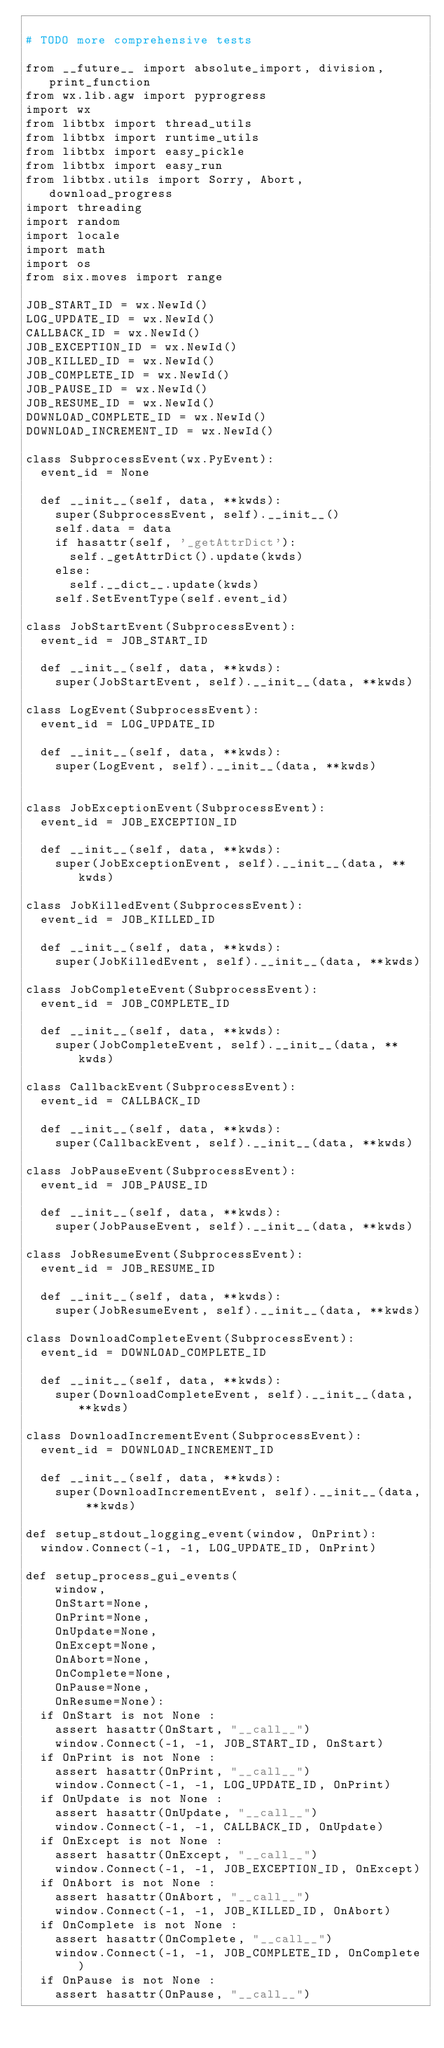Convert code to text. <code><loc_0><loc_0><loc_500><loc_500><_Python_>
# TODO more comprehensive tests

from __future__ import absolute_import, division, print_function
from wx.lib.agw import pyprogress
import wx
from libtbx import thread_utils
from libtbx import runtime_utils
from libtbx import easy_pickle
from libtbx import easy_run
from libtbx.utils import Sorry, Abort, download_progress
import threading
import random
import locale
import math
import os
from six.moves import range

JOB_START_ID = wx.NewId()
LOG_UPDATE_ID = wx.NewId()
CALLBACK_ID = wx.NewId()
JOB_EXCEPTION_ID = wx.NewId()
JOB_KILLED_ID = wx.NewId()
JOB_COMPLETE_ID = wx.NewId()
JOB_PAUSE_ID = wx.NewId()
JOB_RESUME_ID = wx.NewId()
DOWNLOAD_COMPLETE_ID = wx.NewId()
DOWNLOAD_INCREMENT_ID = wx.NewId()

class SubprocessEvent(wx.PyEvent):
  event_id = None

  def __init__(self, data, **kwds):
    super(SubprocessEvent, self).__init__()
    self.data = data
    if hasattr(self, '_getAttrDict'):
      self._getAttrDict().update(kwds)
    else:
      self.__dict__.update(kwds)
    self.SetEventType(self.event_id)

class JobStartEvent(SubprocessEvent):
  event_id = JOB_START_ID

  def __init__(self, data, **kwds):
    super(JobStartEvent, self).__init__(data, **kwds)

class LogEvent(SubprocessEvent):
  event_id = LOG_UPDATE_ID

  def __init__(self, data, **kwds):
    super(LogEvent, self).__init__(data, **kwds)


class JobExceptionEvent(SubprocessEvent):
  event_id = JOB_EXCEPTION_ID

  def __init__(self, data, **kwds):
    super(JobExceptionEvent, self).__init__(data, **kwds)

class JobKilledEvent(SubprocessEvent):
  event_id = JOB_KILLED_ID

  def __init__(self, data, **kwds):
    super(JobKilledEvent, self).__init__(data, **kwds)

class JobCompleteEvent(SubprocessEvent):
  event_id = JOB_COMPLETE_ID

  def __init__(self, data, **kwds):
    super(JobCompleteEvent, self).__init__(data, **kwds)

class CallbackEvent(SubprocessEvent):
  event_id = CALLBACK_ID

  def __init__(self, data, **kwds):
    super(CallbackEvent, self).__init__(data, **kwds)

class JobPauseEvent(SubprocessEvent):
  event_id = JOB_PAUSE_ID

  def __init__(self, data, **kwds):
    super(JobPauseEvent, self).__init__(data, **kwds)

class JobResumeEvent(SubprocessEvent):
  event_id = JOB_RESUME_ID

  def __init__(self, data, **kwds):
    super(JobResumeEvent, self).__init__(data, **kwds)

class DownloadCompleteEvent(SubprocessEvent):
  event_id = DOWNLOAD_COMPLETE_ID

  def __init__(self, data, **kwds):
    super(DownloadCompleteEvent, self).__init__(data, **kwds)

class DownloadIncrementEvent(SubprocessEvent):
  event_id = DOWNLOAD_INCREMENT_ID

  def __init__(self, data, **kwds):
    super(DownloadIncrementEvent, self).__init__(data, **kwds)

def setup_stdout_logging_event(window, OnPrint):
  window.Connect(-1, -1, LOG_UPDATE_ID, OnPrint)

def setup_process_gui_events(
    window,
    OnStart=None,
    OnPrint=None,
    OnUpdate=None,
    OnExcept=None,
    OnAbort=None,
    OnComplete=None,
    OnPause=None,
    OnResume=None):
  if OnStart is not None :
    assert hasattr(OnStart, "__call__")
    window.Connect(-1, -1, JOB_START_ID, OnStart)
  if OnPrint is not None :
    assert hasattr(OnPrint, "__call__")
    window.Connect(-1, -1, LOG_UPDATE_ID, OnPrint)
  if OnUpdate is not None :
    assert hasattr(OnUpdate, "__call__")
    window.Connect(-1, -1, CALLBACK_ID, OnUpdate)
  if OnExcept is not None :
    assert hasattr(OnExcept, "__call__")
    window.Connect(-1, -1, JOB_EXCEPTION_ID, OnExcept)
  if OnAbort is not None :
    assert hasattr(OnAbort, "__call__")
    window.Connect(-1, -1, JOB_KILLED_ID, OnAbort)
  if OnComplete is not None :
    assert hasattr(OnComplete, "__call__")
    window.Connect(-1, -1, JOB_COMPLETE_ID, OnComplete)
  if OnPause is not None :
    assert hasattr(OnPause, "__call__")</code> 